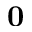<formula> <loc_0><loc_0><loc_500><loc_500>0</formula> 